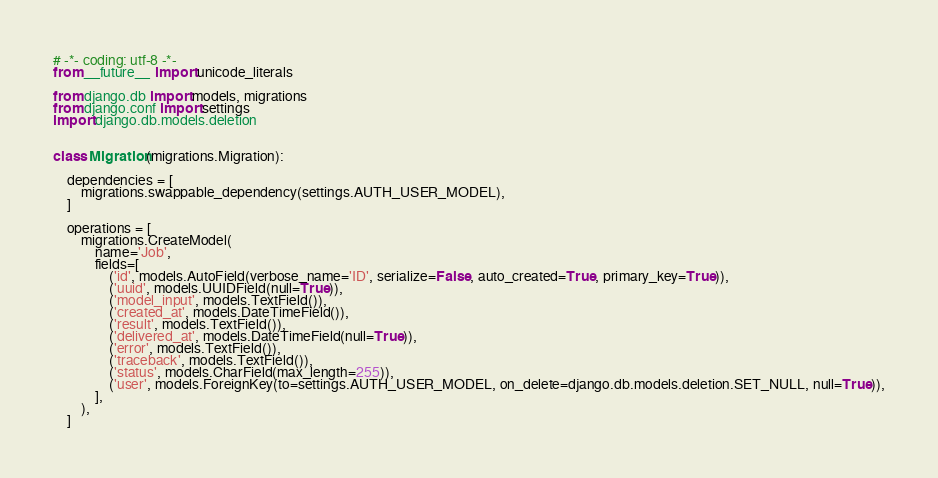Convert code to text. <code><loc_0><loc_0><loc_500><loc_500><_Python_># -*- coding: utf-8 -*-
from __future__ import unicode_literals

from django.db import models, migrations
from django.conf import settings
import django.db.models.deletion


class Migration(migrations.Migration):

    dependencies = [
        migrations.swappable_dependency(settings.AUTH_USER_MODEL),
    ]

    operations = [
        migrations.CreateModel(
            name='Job',
            fields=[
                ('id', models.AutoField(verbose_name='ID', serialize=False, auto_created=True, primary_key=True)),
                ('uuid', models.UUIDField(null=True)),
                ('model_input', models.TextField()),
                ('created_at', models.DateTimeField()),
                ('result', models.TextField()),
                ('delivered_at', models.DateTimeField(null=True)),
                ('error', models.TextField()),
                ('traceback', models.TextField()),
                ('status', models.CharField(max_length=255)),
                ('user', models.ForeignKey(to=settings.AUTH_USER_MODEL, on_delete=django.db.models.deletion.SET_NULL, null=True)),
            ],
        ),
    ]
</code> 